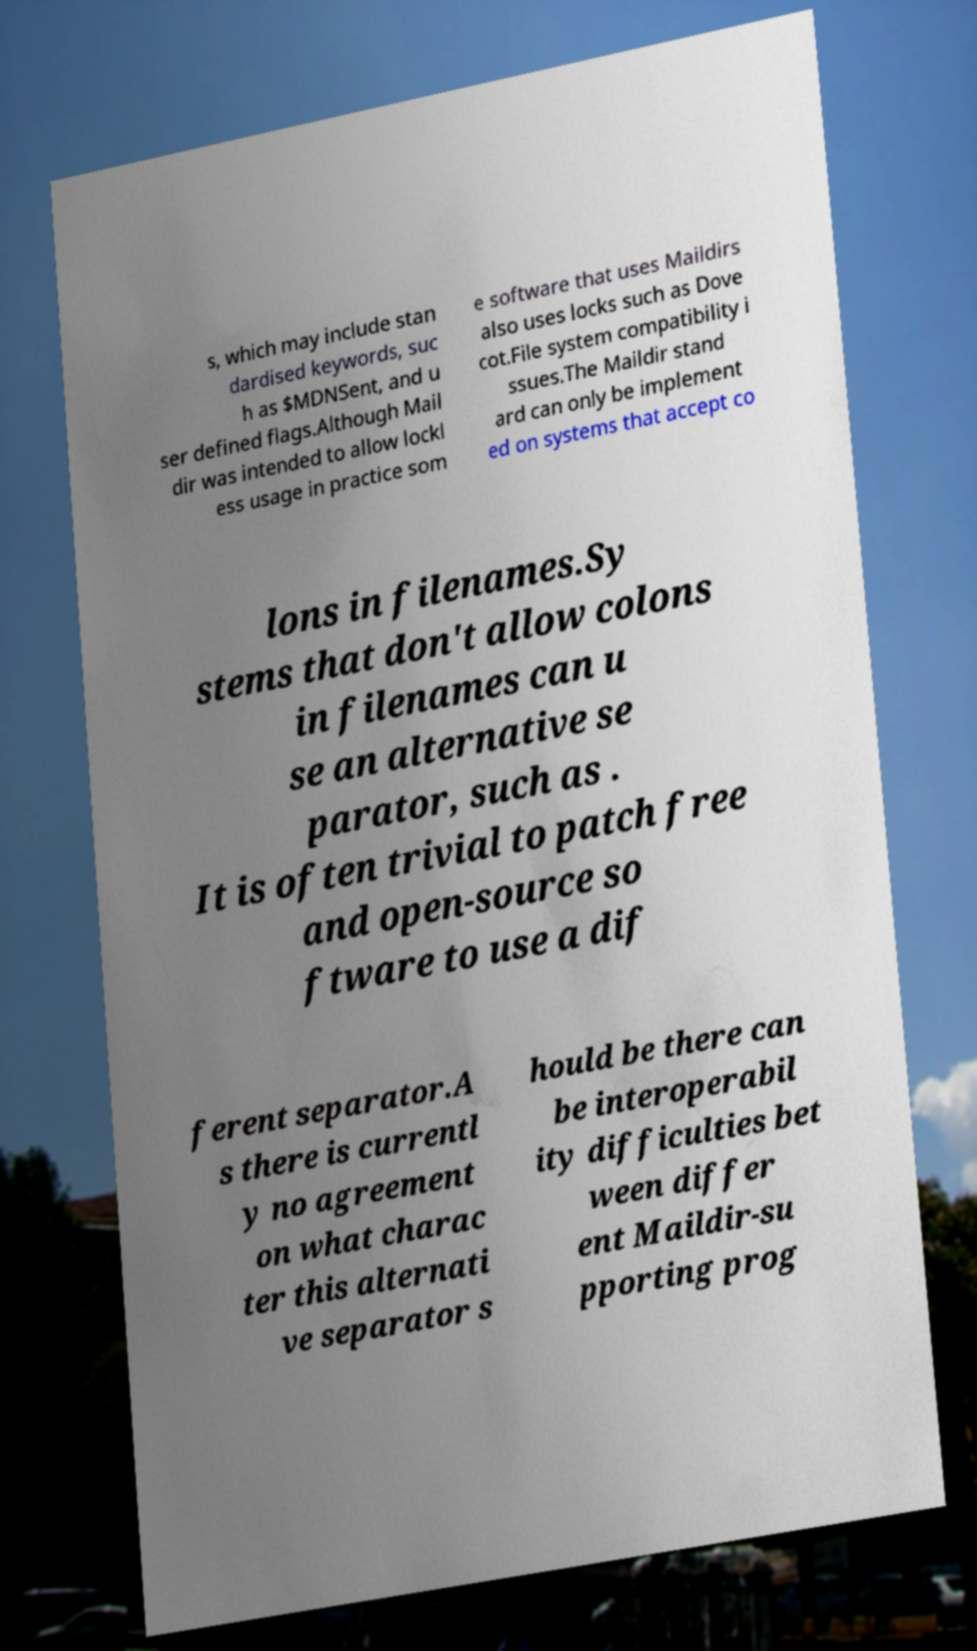For documentation purposes, I need the text within this image transcribed. Could you provide that? s, which may include stan dardised keywords, suc h as $MDNSent, and u ser defined flags.Although Mail dir was intended to allow lockl ess usage in practice som e software that uses Maildirs also uses locks such as Dove cot.File system compatibility i ssues.The Maildir stand ard can only be implement ed on systems that accept co lons in filenames.Sy stems that don't allow colons in filenames can u se an alternative se parator, such as . It is often trivial to patch free and open-source so ftware to use a dif ferent separator.A s there is currentl y no agreement on what charac ter this alternati ve separator s hould be there can be interoperabil ity difficulties bet ween differ ent Maildir-su pporting prog 